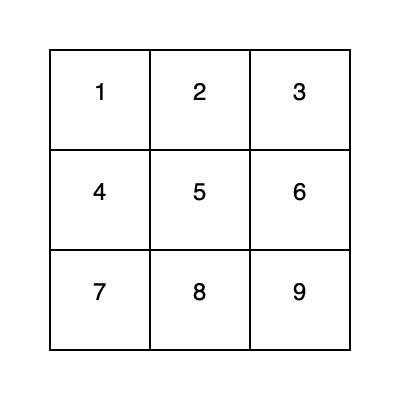In an open-world game, you find a unique cube-shaped item. The image shows the unfolded net of this cube. If face 1 is the top of the cube, which face would be directly opposite to it when the cube is folded? To determine the opposite face of a cube, we need to visualize how the net folds into a 3D shape:

1. Face 1 is given as the top face.
2. In a cube, opposite faces are always separated by one face in the net.
3. Looking at the net, we can see that faces 2, 4, 5, and 6 are adjacent to face 1.
4. The only face that is not adjacent to face 1 and is separated by exactly one face is face 9.
5. When folded, face 9 would be on the bottom of the cube, directly opposite to face 1.

This spatial reasoning is crucial in many open-world games, especially those with puzzle elements or inventory management systems that require players to manipulate 3D objects.
Answer: 9 